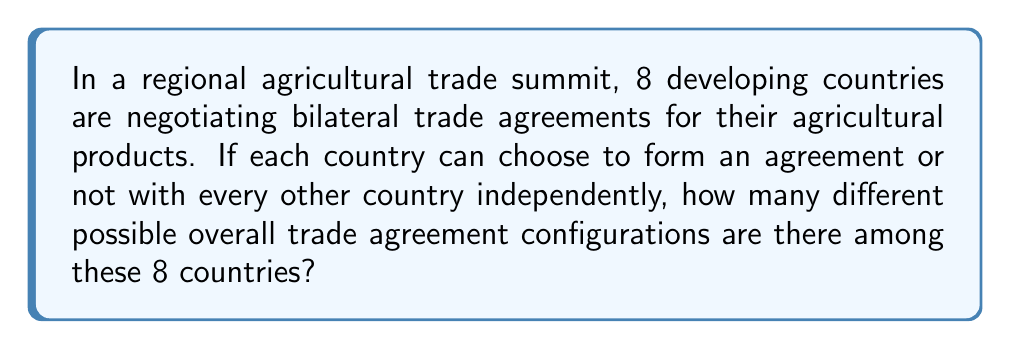Can you solve this math problem? Let's approach this step-by-step:

1) First, we need to understand what we're counting. For each pair of countries, there are two possibilities: they either have a trade agreement or they don't.

2) Next, we need to determine how many pairs of countries there are. With 8 countries, we can calculate this using the combination formula:

   $$\binom{8}{2} = \frac{8!}{2!(8-2)!} = \frac{8 \cdot 7}{2} = 28$$

   So there are 28 possible bilateral relationships.

3) For each of these 28 relationships, there are 2 possibilities (agreement or no agreement).

4) This scenario fits the multiplication principle of counting. When we have a series of independent choices, we multiply the number of options for each choice.

5) Therefore, the total number of possible configurations is:

   $$2^{28}$$

6) We can calculate this:

   $$2^{28} = 268,435,456$$

This large number illustrates the complexity of international trade negotiations, even with a relatively small number of countries involved.
Answer: $2^{28} = 268,435,456$ 